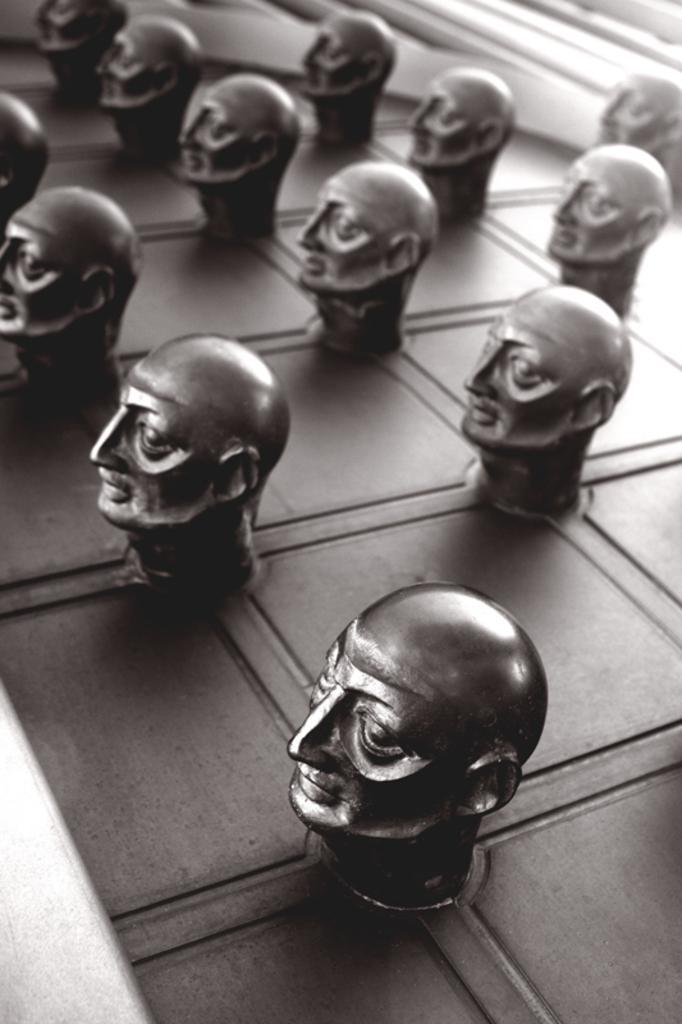Describe this image in one or two sentences. In this image I can see number of sculptures. I can also see this image is black and white in color. 